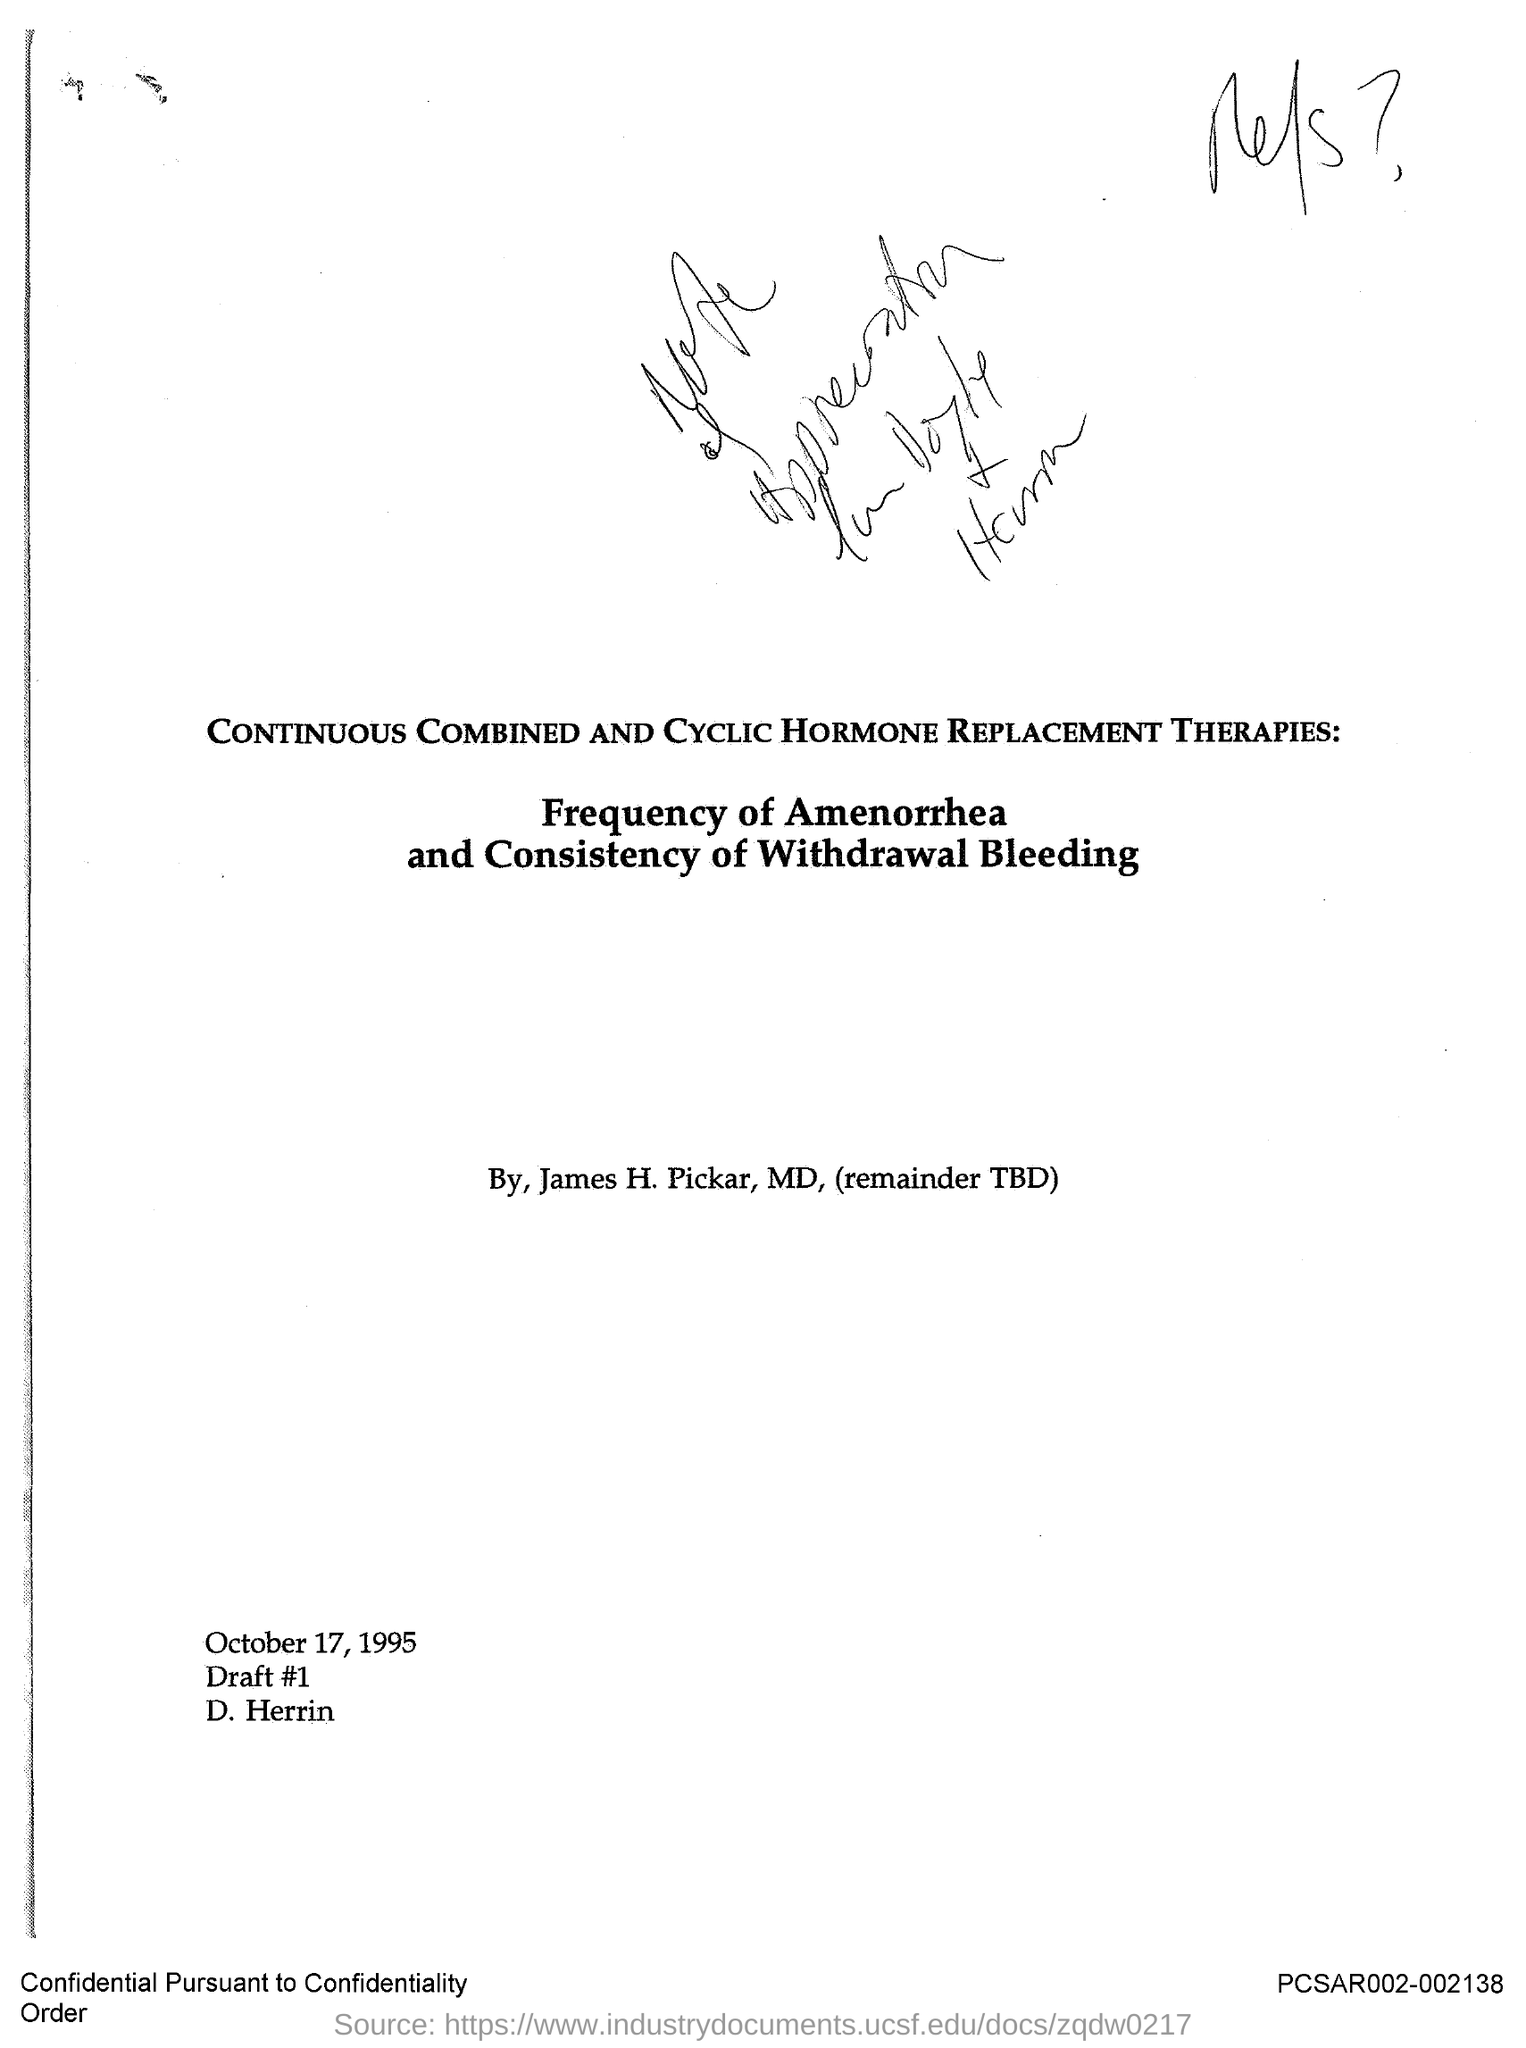What is the main heading?
Offer a terse response. CONTINUOUS COMBINED AND CYCLIC HORMONE REPLACEMENT THERAPIES. What is the sub heading?
Make the answer very short. FREQUENCY OF AMENORRHEA AND CONSISTENCY OF WITHDRAWAL BLEEDING. Who is the author?
Provide a succinct answer. JAMES H. PICKAR. What is the date?
Your answer should be very brief. OCTOBER 17, 1995. What is the draft #?
Offer a terse response. 1. Who has drafted it?
Provide a short and direct response. D. Herrin. 